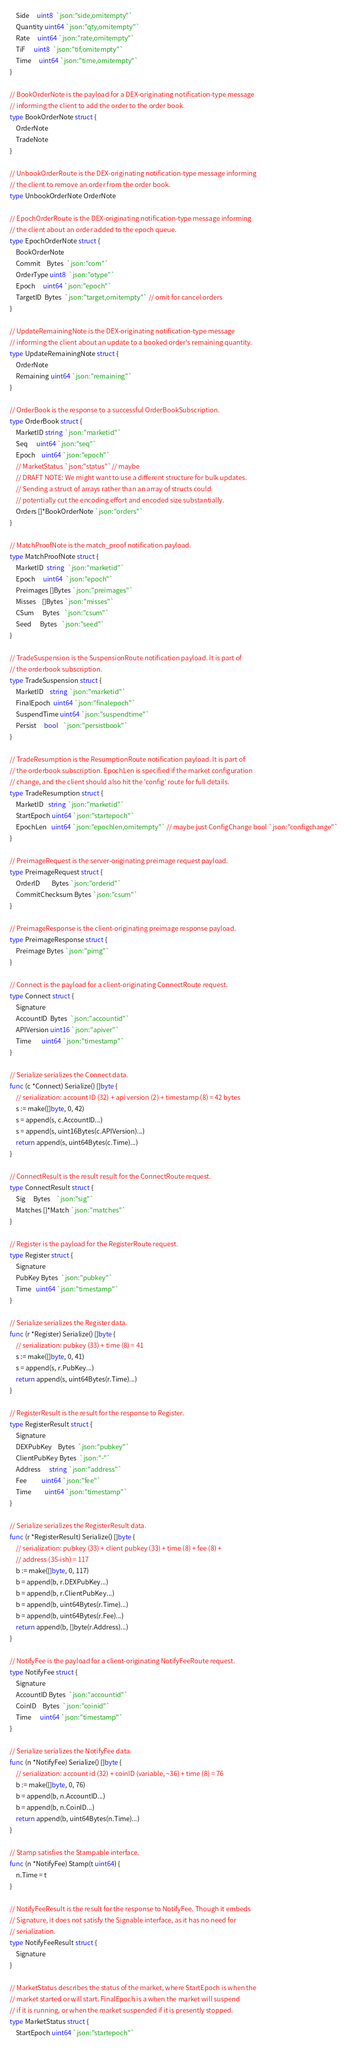Convert code to text. <code><loc_0><loc_0><loc_500><loc_500><_Go_>	Side     uint8  `json:"side,omitempty"`
	Quantity uint64 `json:"qty,omitempty"`
	Rate     uint64 `json:"rate,omitempty"`
	TiF      uint8  `json:"tif,omitempty"`
	Time     uint64 `json:"time,omitempty"`
}

// BookOrderNote is the payload for a DEX-originating notification-type message
// informing the client to add the order to the order book.
type BookOrderNote struct {
	OrderNote
	TradeNote
}

// UnbookOrderRoute is the DEX-originating notification-type message informing
// the client to remove an order from the order book.
type UnbookOrderNote OrderNote

// EpochOrderRoute is the DEX-originating notification-type message informing
// the client about an order added to the epoch queue.
type EpochOrderNote struct {
	BookOrderNote
	Commit    Bytes  `json:"com"`
	OrderType uint8  `json:"otype"`
	Epoch     uint64 `json:"epoch"`
	TargetID  Bytes  `json:"target,omitempty"` // omit for cancel orders
}

// UpdateRemainingNote is the DEX-originating notification-type message
// informing the client about an update to a booked order's remaining quantity.
type UpdateRemainingNote struct {
	OrderNote
	Remaining uint64 `json:"remaining"`
}

// OrderBook is the response to a successful OrderBookSubscription.
type OrderBook struct {
	MarketID string `json:"marketid"`
	Seq      uint64 `json:"seq"`
	Epoch    uint64 `json:"epoch"`
	// MarketStatus `json:"status"`// maybe
	// DRAFT NOTE: We might want to use a different structure for bulk updates.
	// Sending a struct of arrays rather than an array of structs could
	// potentially cut the encoding effort and encoded size substantially.
	Orders []*BookOrderNote `json:"orders"`
}

// MatchProofNote is the match_proof notification payload.
type MatchProofNote struct {
	MarketID  string  `json:"marketid"`
	Epoch     uint64  `json:"epoch"`
	Preimages []Bytes `json:"preimages"`
	Misses    []Bytes `json:"misses"`
	CSum      Bytes   `json:"csum"`
	Seed      Bytes   `json:"seed"`
}

// TradeSuspension is the SuspensionRoute notification payload. It is part of
// the orderbook subscription.
type TradeSuspension struct {
	MarketID    string `json:"marketid"`
	FinalEpoch  uint64 `json:"finalepoch"`
	SuspendTime uint64 `json:"suspendtime"`
	Persist     bool   `json:"persistbook"`
}

// TradeResumption is the ResumptionRoute notification payload. It is part of
// the orderbook subscription. EpochLen is specified if the market configuration
// change, and the client should also hit the 'config' route for full details.
type TradeResumption struct {
	MarketID   string `json:"marketid"`
	StartEpoch uint64 `json:"startepoch"`
	EpochLen   uint64 `json:"epochlen,omitempty"` // maybe just ConfigChange bool `json:"configchange"`
}

// PreimageRequest is the server-originating preimage request payload.
type PreimageRequest struct {
	OrderID        Bytes `json:"orderid"`
	CommitChecksum Bytes `json:"csum"`
}

// PreimageResponse is the client-originating preimage response payload.
type PreimageResponse struct {
	Preimage Bytes `json:"pimg"`
}

// Connect is the payload for a client-originating ConnectRoute request.
type Connect struct {
	Signature
	AccountID  Bytes  `json:"accountid"`
	APIVersion uint16 `json:"apiver"`
	Time       uint64 `json:"timestamp"`
}

// Serialize serializes the Connect data.
func (c *Connect) Serialize() []byte {
	// serialization: account ID (32) + api version (2) + timestamp (8) = 42 bytes
	s := make([]byte, 0, 42)
	s = append(s, c.AccountID...)
	s = append(s, uint16Bytes(c.APIVersion)...)
	return append(s, uint64Bytes(c.Time)...)
}

// ConnectResult is the result result for the ConnectRoute request.
type ConnectResult struct {
	Sig     Bytes    `json:"sig"`
	Matches []*Match `json:"matches"`
}

// Register is the payload for the RegisterRoute request.
type Register struct {
	Signature
	PubKey Bytes  `json:"pubkey"`
	Time   uint64 `json:"timestamp"`
}

// Serialize serializes the Register data.
func (r *Register) Serialize() []byte {
	// serialization: pubkey (33) + time (8) = 41
	s := make([]byte, 0, 41)
	s = append(s, r.PubKey...)
	return append(s, uint64Bytes(r.Time)...)
}

// RegisterResult is the result for the response to Register.
type RegisterResult struct {
	Signature
	DEXPubKey    Bytes  `json:"pubkey"`
	ClientPubKey Bytes  `json:"-"`
	Address      string `json:"address"`
	Fee          uint64 `json:"fee"`
	Time         uint64 `json:"timestamp"`
}

// Serialize serializes the RegisterResult data.
func (r *RegisterResult) Serialize() []byte {
	// serialization: pubkey (33) + client pubkey (33) + time (8) + fee (8) +
	// address (35-ish) = 117
	b := make([]byte, 0, 117)
	b = append(b, r.DEXPubKey...)
	b = append(b, r.ClientPubKey...)
	b = append(b, uint64Bytes(r.Time)...)
	b = append(b, uint64Bytes(r.Fee)...)
	return append(b, []byte(r.Address)...)
}

// NotifyFee is the payload for a client-originating NotifyFeeRoute request.
type NotifyFee struct {
	Signature
	AccountID Bytes  `json:"accountid"`
	CoinID    Bytes  `json:"coinid"`
	Time      uint64 `json:"timestamp"`
}

// Serialize serializes the NotifyFee data.
func (n *NotifyFee) Serialize() []byte {
	// serialization: account id (32) + coinID (variable, ~36) + time (8) = 76
	b := make([]byte, 0, 76)
	b = append(b, n.AccountID...)
	b = append(b, n.CoinID...)
	return append(b, uint64Bytes(n.Time)...)
}

// Stamp satisfies the Stampable interface.
func (n *NotifyFee) Stamp(t uint64) {
	n.Time = t
}

// NotifyFeeResult is the result for the response to NotifyFee. Though it embeds
// Signature, it does not satisfy the Signable interface, as it has no need for
// serialization.
type NotifyFeeResult struct {
	Signature
}

// MarketStatus describes the status of the market, where StartEpoch is when the
// market started or will start. FinalEpoch is a when the market will suspend
// if it is running, or when the market suspended if it is presently stopped.
type MarketStatus struct {
	StartEpoch uint64 `json:"startepoch"`</code> 